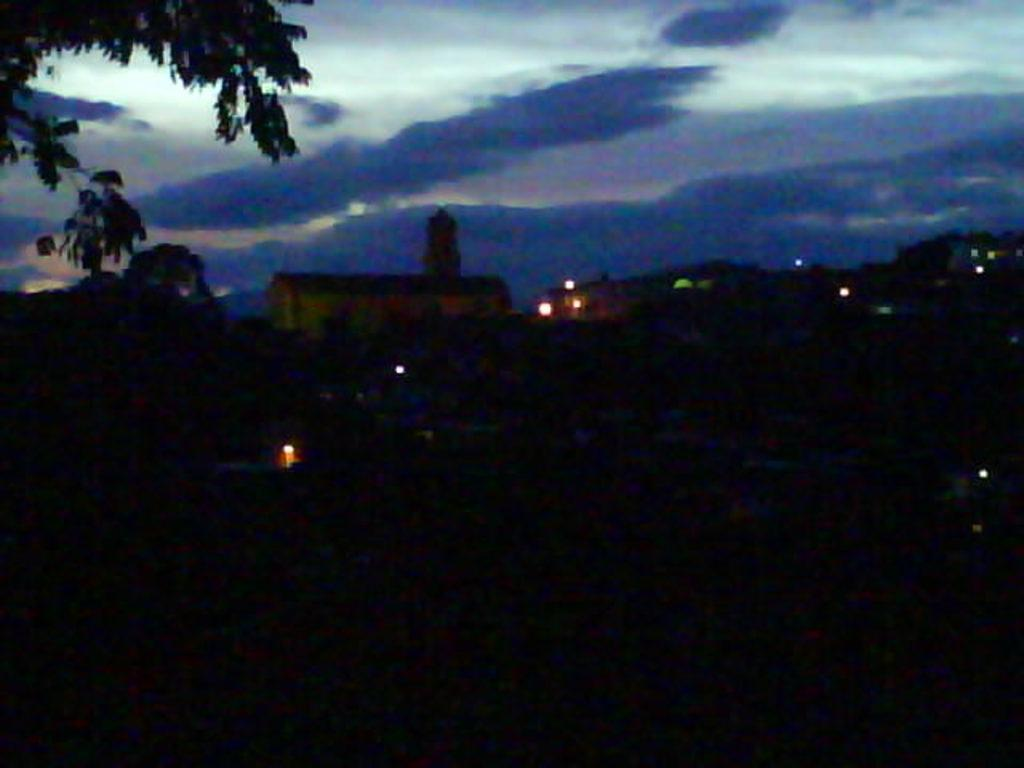What time of day was the image taken? The image was taken at night. What can be seen in some parts of the image? There are lights visible in some parts of the image. What is visible at the top of the image? The sky is visible at the top of the image. What type of vegetation is on the left side of the image? There are leaves on the left side of the image. What type of stove can be seen in the image? There is no stove present in the image. What type of stew is being prepared in the image? There is no stew or cooking activity depicted in the image. 